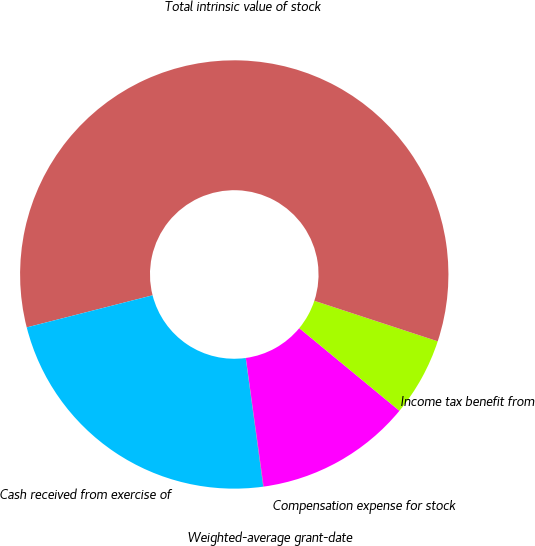Convert chart. <chart><loc_0><loc_0><loc_500><loc_500><pie_chart><fcel>Compensation expense for stock<fcel>Income tax benefit from<fcel>Total intrinsic value of stock<fcel>Cash received from exercise of<fcel>Weighted-average grant-date<nl><fcel>11.83%<fcel>5.93%<fcel>59.03%<fcel>23.19%<fcel>0.03%<nl></chart> 